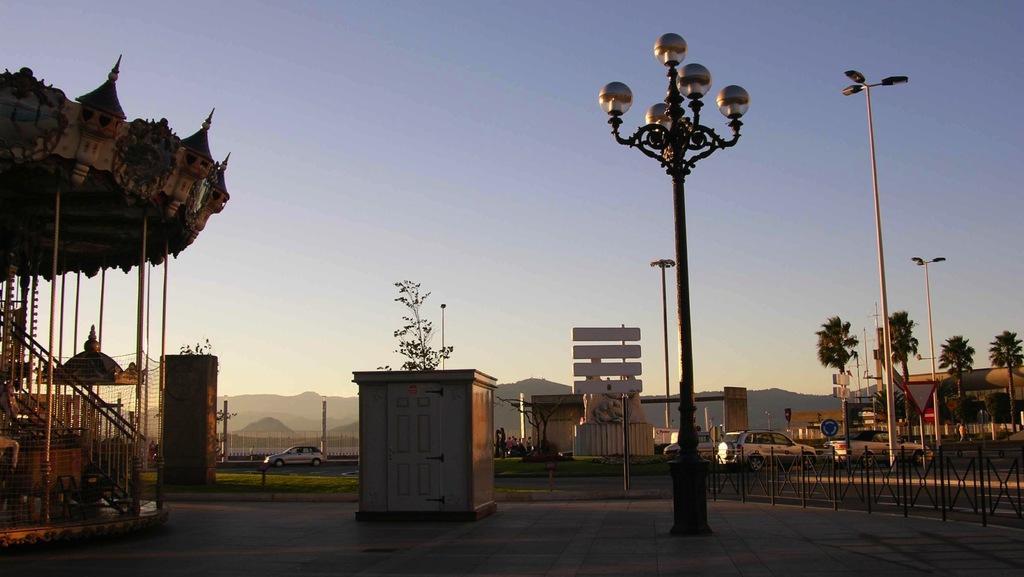How would you summarize this image in a sentence or two? In this image I can see the ground, a black colored pole, a small shed, the railing, few street light poles, few trees, few vehicles on the road and a structure which is made up of metal rods and the roof. In the background I can see few mountains, few trees and the sky. 